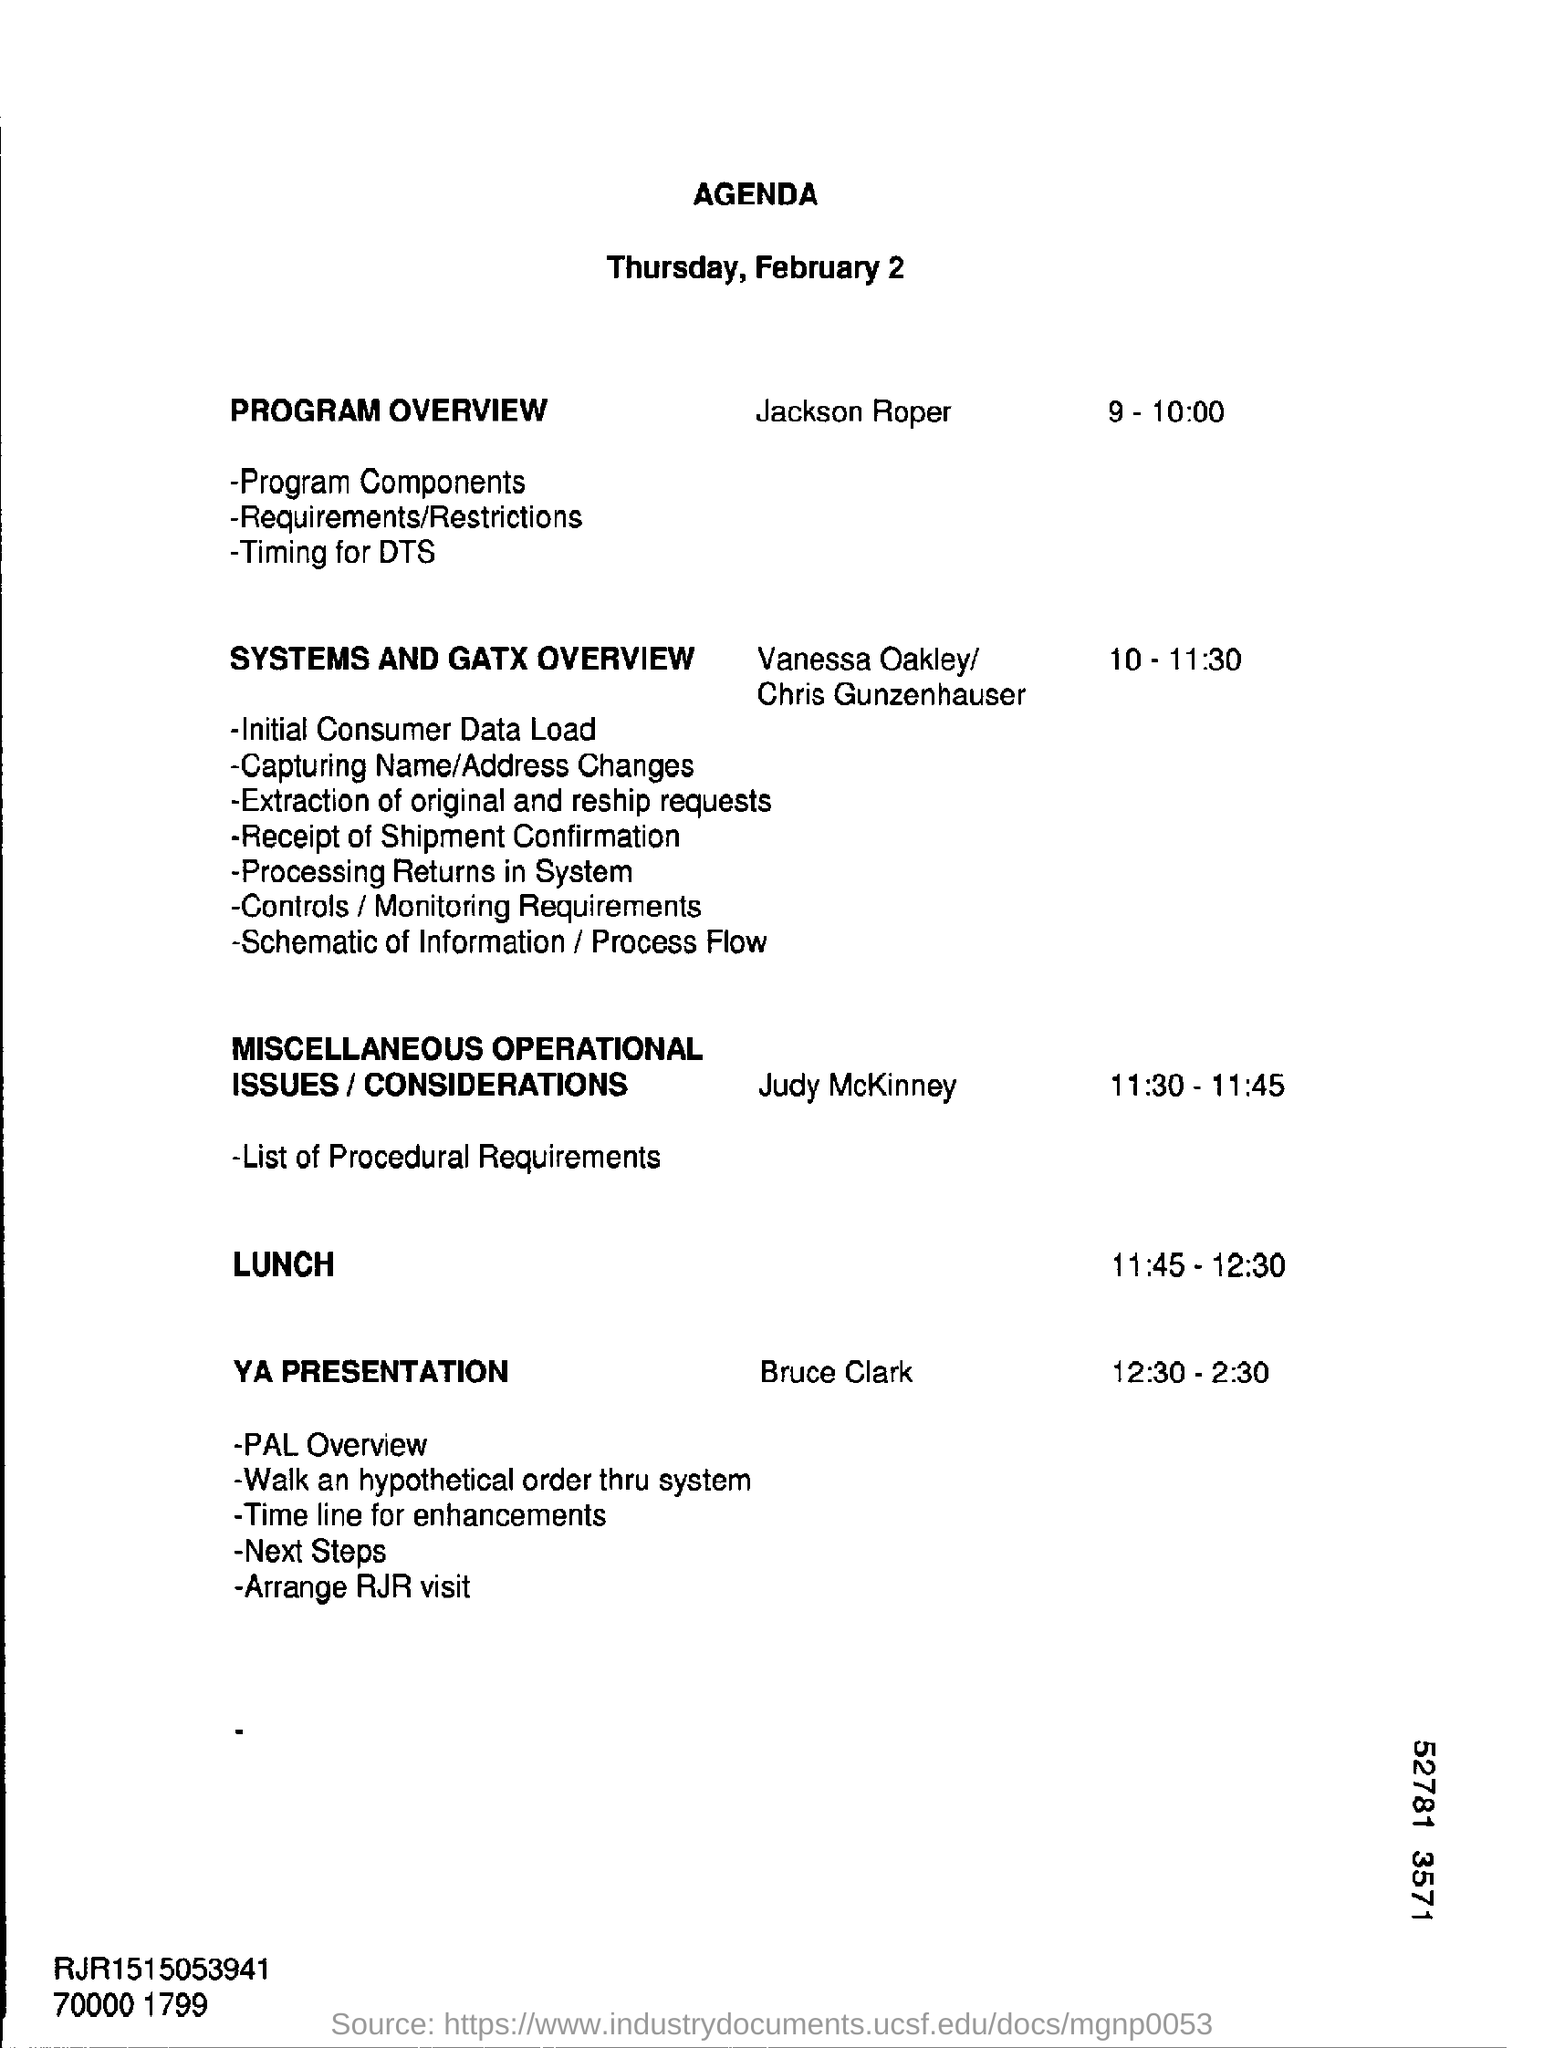For what date , the agenda is prepared?
Make the answer very short. Thursday, February 2. Who is presenting the program overview?
Keep it short and to the point. Jackson Roper. At what time, the systems and gatx overview is scheduled?
Provide a short and direct response. 10 - 11:30. Who is doing the YA Presentation?
Your response must be concise. Bruce Clark. At what time, the lunch is provided?
Provide a succinct answer. 11:45 - 12:30. 